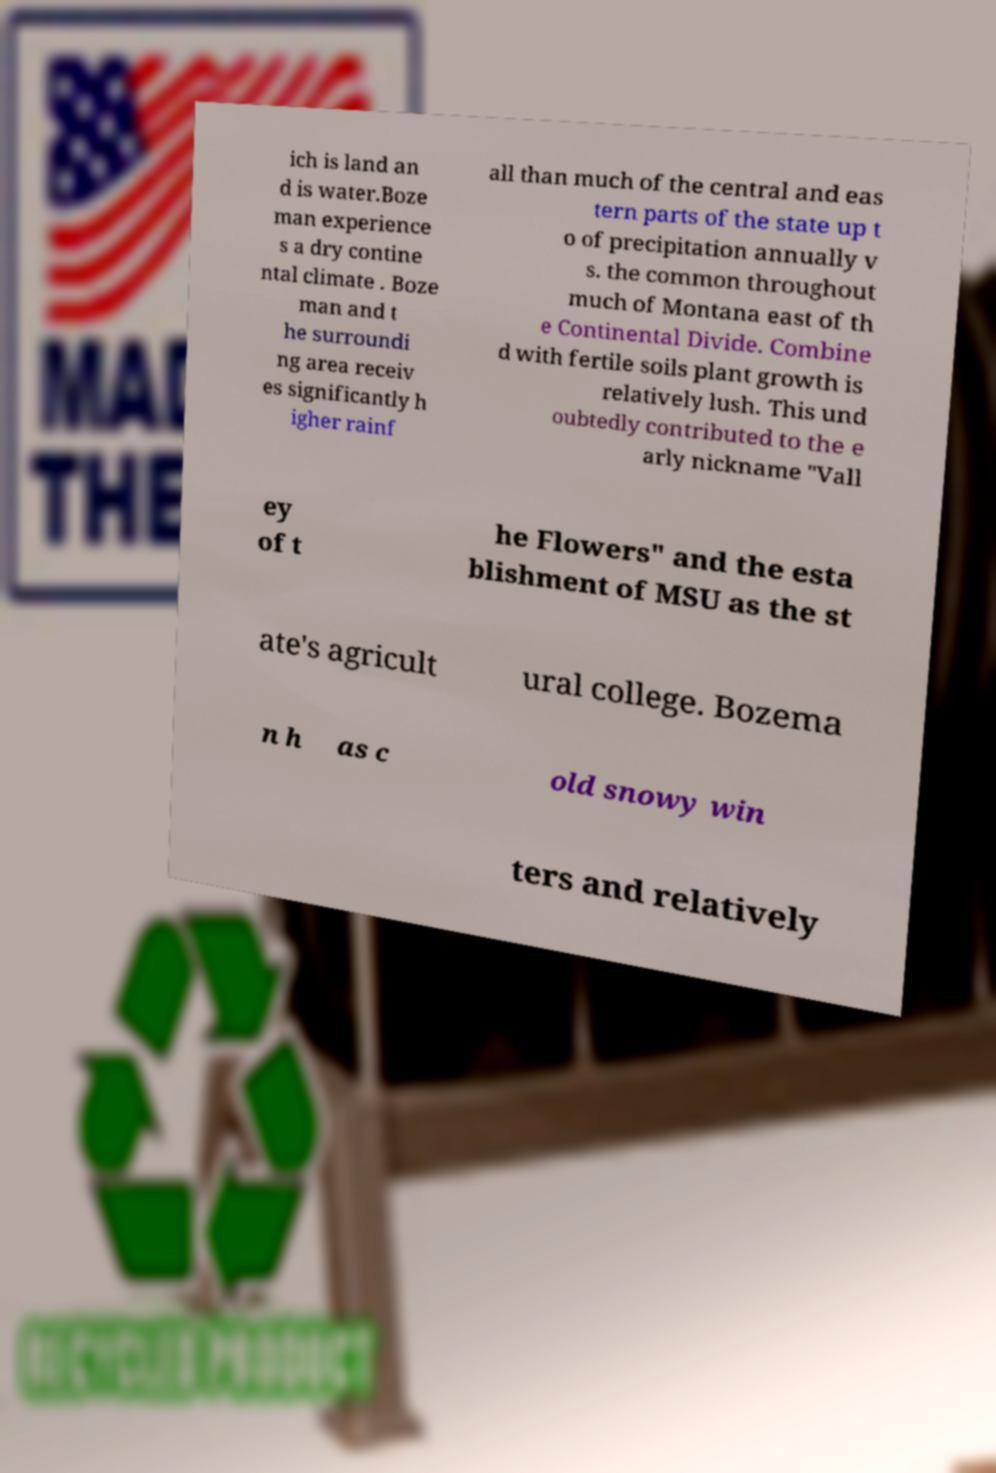Can you read and provide the text displayed in the image?This photo seems to have some interesting text. Can you extract and type it out for me? ich is land an d is water.Boze man experience s a dry contine ntal climate . Boze man and t he surroundi ng area receiv es significantly h igher rainf all than much of the central and eas tern parts of the state up t o of precipitation annually v s. the common throughout much of Montana east of th e Continental Divide. Combine d with fertile soils plant growth is relatively lush. This und oubtedly contributed to the e arly nickname "Vall ey of t he Flowers" and the esta blishment of MSU as the st ate's agricult ural college. Bozema n h as c old snowy win ters and relatively 